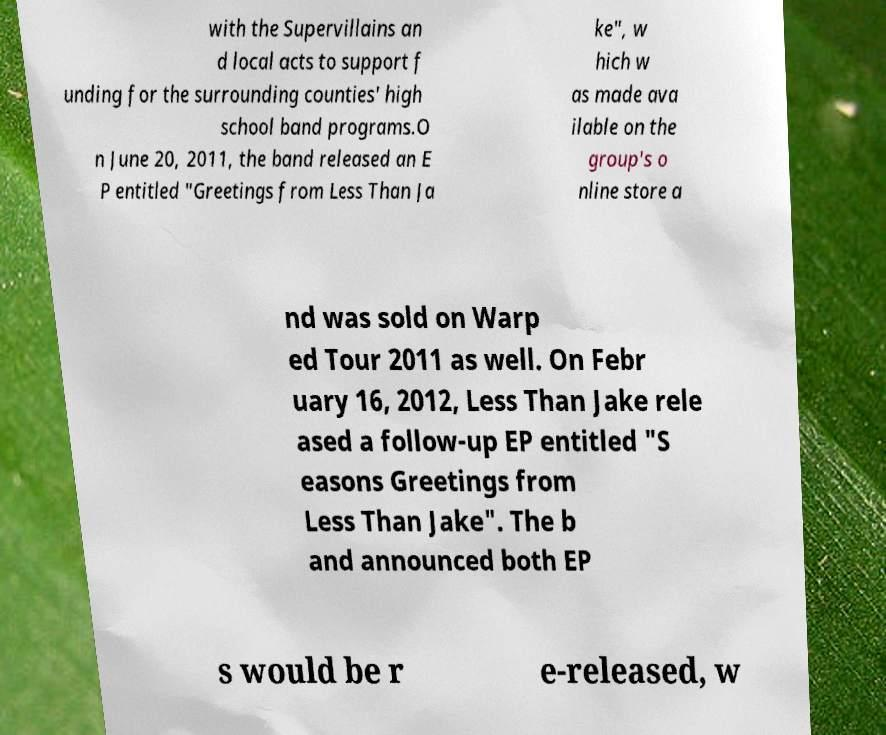There's text embedded in this image that I need extracted. Can you transcribe it verbatim? with the Supervillains an d local acts to support f unding for the surrounding counties' high school band programs.O n June 20, 2011, the band released an E P entitled "Greetings from Less Than Ja ke", w hich w as made ava ilable on the group's o nline store a nd was sold on Warp ed Tour 2011 as well. On Febr uary 16, 2012, Less Than Jake rele ased a follow-up EP entitled "S easons Greetings from Less Than Jake". The b and announced both EP s would be r e-released, w 